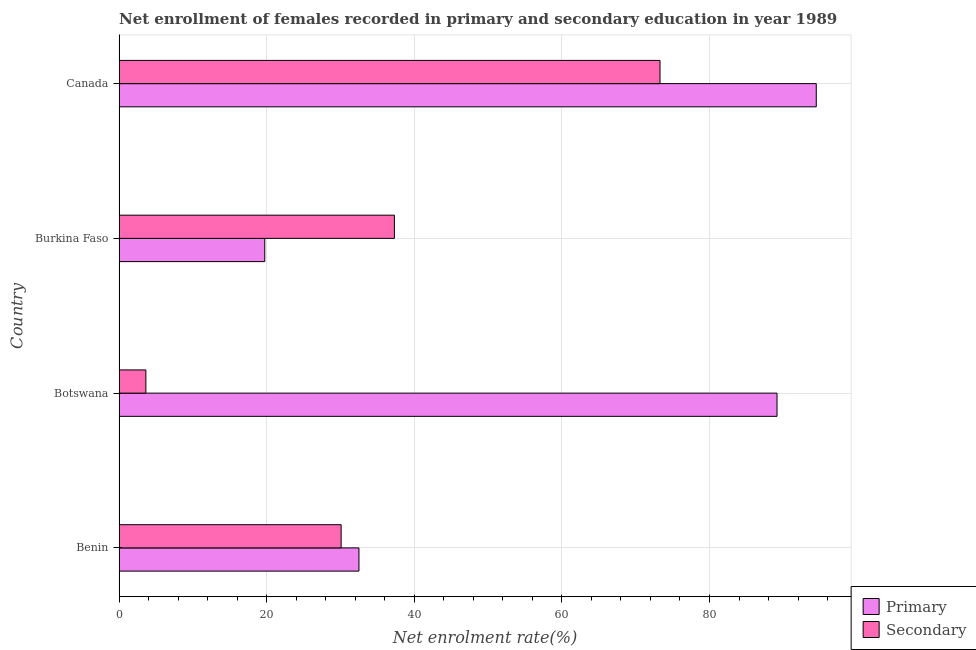How many groups of bars are there?
Your answer should be compact. 4. Are the number of bars on each tick of the Y-axis equal?
Make the answer very short. Yes. How many bars are there on the 4th tick from the top?
Offer a very short reply. 2. How many bars are there on the 2nd tick from the bottom?
Give a very brief answer. 2. What is the label of the 4th group of bars from the top?
Offer a very short reply. Benin. What is the enrollment rate in primary education in Benin?
Give a very brief answer. 32.5. Across all countries, what is the maximum enrollment rate in secondary education?
Your response must be concise. 73.3. Across all countries, what is the minimum enrollment rate in primary education?
Offer a terse response. 19.74. In which country was the enrollment rate in primary education minimum?
Your answer should be very brief. Burkina Faso. What is the total enrollment rate in primary education in the graph?
Your response must be concise. 235.87. What is the difference between the enrollment rate in secondary education in Botswana and that in Canada?
Make the answer very short. -69.66. What is the difference between the enrollment rate in primary education in Benin and the enrollment rate in secondary education in Burkina Faso?
Offer a terse response. -4.8. What is the average enrollment rate in secondary education per country?
Give a very brief answer. 36.08. What is the difference between the enrollment rate in secondary education and enrollment rate in primary education in Benin?
Ensure brevity in your answer.  -2.41. What is the ratio of the enrollment rate in primary education in Benin to that in Canada?
Give a very brief answer. 0.34. Is the difference between the enrollment rate in primary education in Benin and Burkina Faso greater than the difference between the enrollment rate in secondary education in Benin and Burkina Faso?
Offer a very short reply. Yes. What is the difference between the highest and the second highest enrollment rate in primary education?
Give a very brief answer. 5.32. What is the difference between the highest and the lowest enrollment rate in primary education?
Your answer should be compact. 74.73. What does the 1st bar from the top in Botswana represents?
Keep it short and to the point. Secondary. What does the 2nd bar from the bottom in Botswana represents?
Give a very brief answer. Secondary. How many countries are there in the graph?
Provide a short and direct response. 4. What is the difference between two consecutive major ticks on the X-axis?
Offer a terse response. 20. Are the values on the major ticks of X-axis written in scientific E-notation?
Keep it short and to the point. No. Does the graph contain any zero values?
Provide a succinct answer. No. Does the graph contain grids?
Keep it short and to the point. Yes. Where does the legend appear in the graph?
Keep it short and to the point. Bottom right. How many legend labels are there?
Provide a short and direct response. 2. How are the legend labels stacked?
Provide a succinct answer. Vertical. What is the title of the graph?
Provide a short and direct response. Net enrollment of females recorded in primary and secondary education in year 1989. What is the label or title of the X-axis?
Offer a terse response. Net enrolment rate(%). What is the Net enrolment rate(%) in Primary in Benin?
Offer a very short reply. 32.5. What is the Net enrolment rate(%) in Secondary in Benin?
Your answer should be very brief. 30.09. What is the Net enrolment rate(%) of Primary in Botswana?
Make the answer very short. 89.15. What is the Net enrolment rate(%) in Secondary in Botswana?
Make the answer very short. 3.63. What is the Net enrolment rate(%) in Primary in Burkina Faso?
Make the answer very short. 19.74. What is the Net enrolment rate(%) of Secondary in Burkina Faso?
Make the answer very short. 37.31. What is the Net enrolment rate(%) of Primary in Canada?
Your response must be concise. 94.47. What is the Net enrolment rate(%) in Secondary in Canada?
Keep it short and to the point. 73.3. Across all countries, what is the maximum Net enrolment rate(%) in Primary?
Provide a short and direct response. 94.47. Across all countries, what is the maximum Net enrolment rate(%) in Secondary?
Provide a succinct answer. 73.3. Across all countries, what is the minimum Net enrolment rate(%) of Primary?
Provide a succinct answer. 19.74. Across all countries, what is the minimum Net enrolment rate(%) of Secondary?
Offer a terse response. 3.63. What is the total Net enrolment rate(%) in Primary in the graph?
Your answer should be compact. 235.87. What is the total Net enrolment rate(%) in Secondary in the graph?
Offer a terse response. 144.33. What is the difference between the Net enrolment rate(%) in Primary in Benin and that in Botswana?
Provide a short and direct response. -56.65. What is the difference between the Net enrolment rate(%) of Secondary in Benin and that in Botswana?
Provide a short and direct response. 26.46. What is the difference between the Net enrolment rate(%) of Primary in Benin and that in Burkina Faso?
Your answer should be very brief. 12.76. What is the difference between the Net enrolment rate(%) in Secondary in Benin and that in Burkina Faso?
Provide a succinct answer. -7.22. What is the difference between the Net enrolment rate(%) of Primary in Benin and that in Canada?
Your answer should be compact. -61.97. What is the difference between the Net enrolment rate(%) in Secondary in Benin and that in Canada?
Offer a very short reply. -43.21. What is the difference between the Net enrolment rate(%) of Primary in Botswana and that in Burkina Faso?
Keep it short and to the point. 69.41. What is the difference between the Net enrolment rate(%) in Secondary in Botswana and that in Burkina Faso?
Offer a terse response. -33.67. What is the difference between the Net enrolment rate(%) of Primary in Botswana and that in Canada?
Your answer should be compact. -5.32. What is the difference between the Net enrolment rate(%) in Secondary in Botswana and that in Canada?
Your response must be concise. -69.66. What is the difference between the Net enrolment rate(%) in Primary in Burkina Faso and that in Canada?
Ensure brevity in your answer.  -74.73. What is the difference between the Net enrolment rate(%) in Secondary in Burkina Faso and that in Canada?
Provide a succinct answer. -35.99. What is the difference between the Net enrolment rate(%) in Primary in Benin and the Net enrolment rate(%) in Secondary in Botswana?
Give a very brief answer. 28.87. What is the difference between the Net enrolment rate(%) in Primary in Benin and the Net enrolment rate(%) in Secondary in Burkina Faso?
Offer a very short reply. -4.8. What is the difference between the Net enrolment rate(%) in Primary in Benin and the Net enrolment rate(%) in Secondary in Canada?
Offer a very short reply. -40.79. What is the difference between the Net enrolment rate(%) of Primary in Botswana and the Net enrolment rate(%) of Secondary in Burkina Faso?
Your response must be concise. 51.85. What is the difference between the Net enrolment rate(%) in Primary in Botswana and the Net enrolment rate(%) in Secondary in Canada?
Your answer should be very brief. 15.86. What is the difference between the Net enrolment rate(%) of Primary in Burkina Faso and the Net enrolment rate(%) of Secondary in Canada?
Your response must be concise. -53.55. What is the average Net enrolment rate(%) of Primary per country?
Provide a short and direct response. 58.97. What is the average Net enrolment rate(%) in Secondary per country?
Give a very brief answer. 36.08. What is the difference between the Net enrolment rate(%) of Primary and Net enrolment rate(%) of Secondary in Benin?
Your response must be concise. 2.41. What is the difference between the Net enrolment rate(%) of Primary and Net enrolment rate(%) of Secondary in Botswana?
Your response must be concise. 85.52. What is the difference between the Net enrolment rate(%) of Primary and Net enrolment rate(%) of Secondary in Burkina Faso?
Give a very brief answer. -17.56. What is the difference between the Net enrolment rate(%) in Primary and Net enrolment rate(%) in Secondary in Canada?
Offer a very short reply. 21.17. What is the ratio of the Net enrolment rate(%) in Primary in Benin to that in Botswana?
Keep it short and to the point. 0.36. What is the ratio of the Net enrolment rate(%) of Secondary in Benin to that in Botswana?
Give a very brief answer. 8.28. What is the ratio of the Net enrolment rate(%) of Primary in Benin to that in Burkina Faso?
Offer a very short reply. 1.65. What is the ratio of the Net enrolment rate(%) of Secondary in Benin to that in Burkina Faso?
Your response must be concise. 0.81. What is the ratio of the Net enrolment rate(%) of Primary in Benin to that in Canada?
Make the answer very short. 0.34. What is the ratio of the Net enrolment rate(%) of Secondary in Benin to that in Canada?
Provide a short and direct response. 0.41. What is the ratio of the Net enrolment rate(%) in Primary in Botswana to that in Burkina Faso?
Provide a short and direct response. 4.52. What is the ratio of the Net enrolment rate(%) in Secondary in Botswana to that in Burkina Faso?
Provide a succinct answer. 0.1. What is the ratio of the Net enrolment rate(%) of Primary in Botswana to that in Canada?
Offer a very short reply. 0.94. What is the ratio of the Net enrolment rate(%) of Secondary in Botswana to that in Canada?
Your answer should be compact. 0.05. What is the ratio of the Net enrolment rate(%) of Primary in Burkina Faso to that in Canada?
Ensure brevity in your answer.  0.21. What is the ratio of the Net enrolment rate(%) in Secondary in Burkina Faso to that in Canada?
Make the answer very short. 0.51. What is the difference between the highest and the second highest Net enrolment rate(%) in Primary?
Offer a terse response. 5.32. What is the difference between the highest and the second highest Net enrolment rate(%) of Secondary?
Offer a very short reply. 35.99. What is the difference between the highest and the lowest Net enrolment rate(%) in Primary?
Offer a very short reply. 74.73. What is the difference between the highest and the lowest Net enrolment rate(%) in Secondary?
Give a very brief answer. 69.66. 